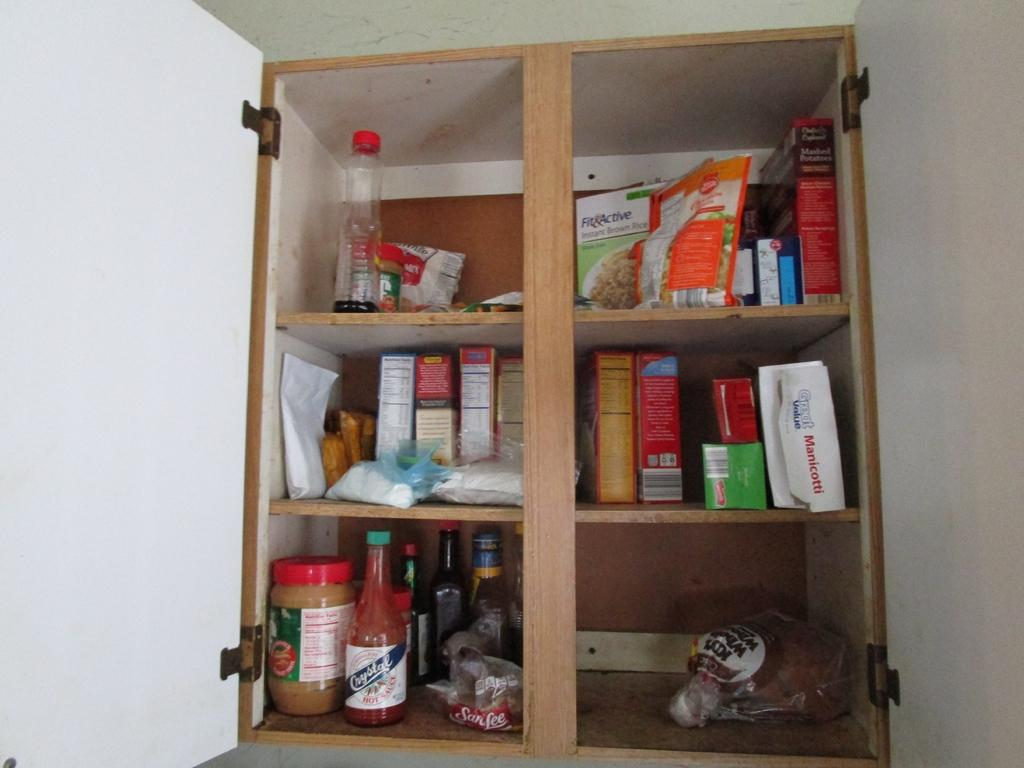<image>
Write a terse but informative summary of the picture. Among the food items in this open cabinet are Great Value Manicotti and Crystal hot sauce. 